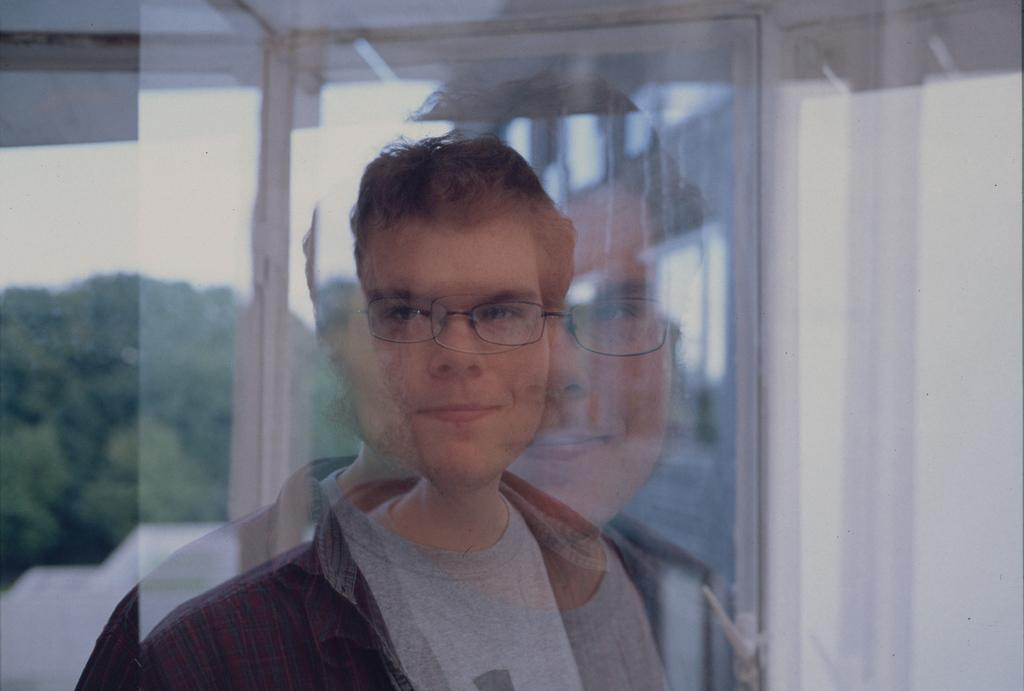What is present in the image? There is a man in the image. What can be seen in the background of the image? There are trees, sky, and walls visible in the background of the image. What type of planes can be seen in the image? There are no planes present in the image. Where is the hospital located in the image? There is no hospital present in the image. 